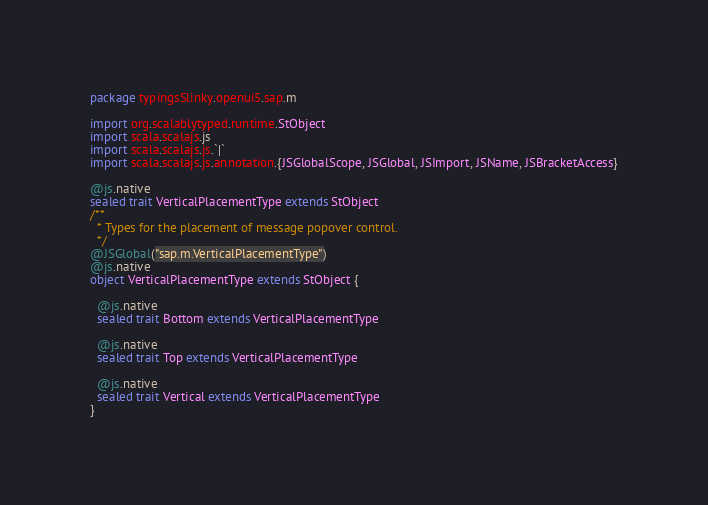Convert code to text. <code><loc_0><loc_0><loc_500><loc_500><_Scala_>package typingsSlinky.openui5.sap.m

import org.scalablytyped.runtime.StObject
import scala.scalajs.js
import scala.scalajs.js.`|`
import scala.scalajs.js.annotation.{JSGlobalScope, JSGlobal, JSImport, JSName, JSBracketAccess}

@js.native
sealed trait VerticalPlacementType extends StObject
/**
  * Types for the placement of message popover control.
  */
@JSGlobal("sap.m.VerticalPlacementType")
@js.native
object VerticalPlacementType extends StObject {
  
  @js.native
  sealed trait Bottom extends VerticalPlacementType
  
  @js.native
  sealed trait Top extends VerticalPlacementType
  
  @js.native
  sealed trait Vertical extends VerticalPlacementType
}
</code> 